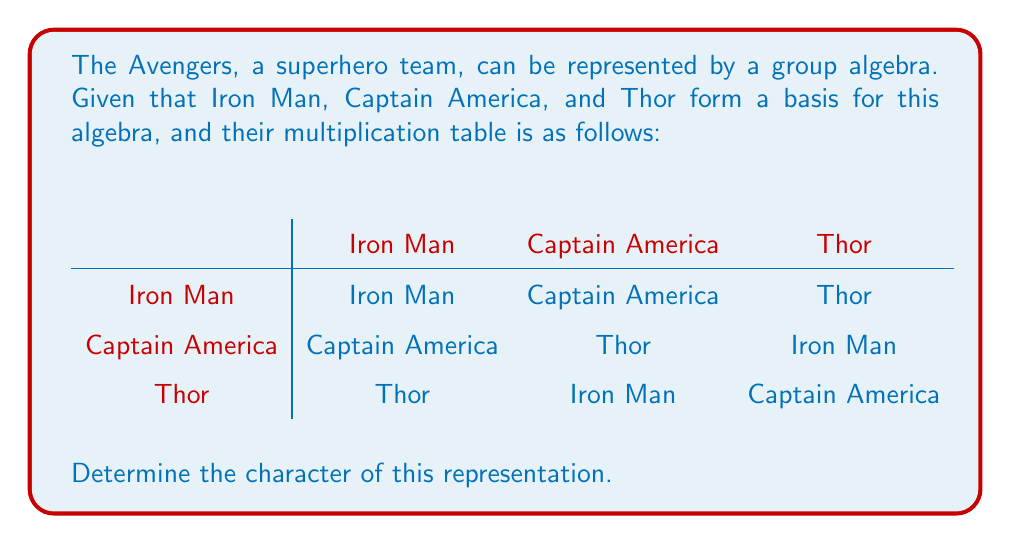Teach me how to tackle this problem. To determine the character of this representation, we need to follow these steps:

1) First, we need to understand that the character of a representation is the trace of the matrix representing each element.

2) From the multiplication table, we can see that this is a regular representation of the cyclic group of order 3, $C_3$.

3) Let's assign variables to our superhero basis:
   Iron Man = $e$
   Captain America = $a$
   Thor = $a^2$

4) Now, we can write out the matrices for each element:

   For $e$ (Iron Man):
   $$\begin{pmatrix}
   1 & 0 & 0 \\
   0 & 1 & 0 \\
   0 & 0 & 1
   \end{pmatrix}$$

   For $a$ (Captain America):
   $$\begin{pmatrix}
   0 & 0 & 1 \\
   1 & 0 & 0 \\
   0 & 1 & 0
   \end{pmatrix}$$

   For $a^2$ (Thor):
   $$\begin{pmatrix}
   0 & 1 & 0 \\
   0 & 0 & 1 \\
   1 & 0 & 0
   \end{pmatrix}$$

5) The character is the trace of each of these matrices:

   $\chi(e) = 1 + 1 + 1 = 3$
   $\chi(a) = 0 + 0 + 0 = 0$
   $\chi(a^2) = 0 + 0 + 0 = 0$

6) Therefore, the character of this representation is $(3, 0, 0)$.
Answer: $(3, 0, 0)$ 